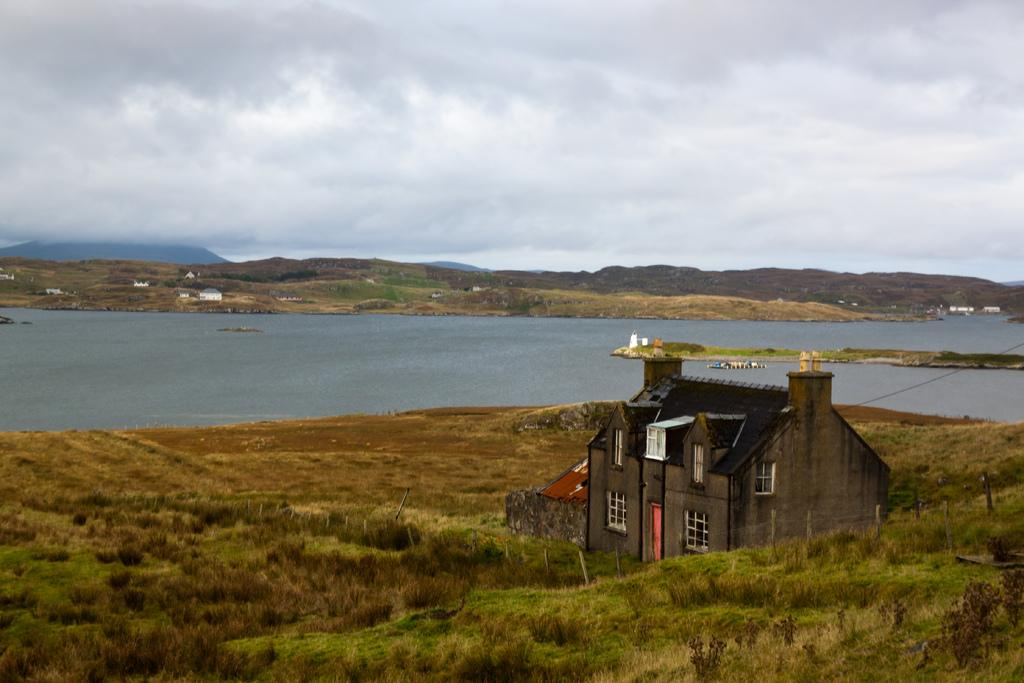What type of structure is present in the image? There is a house in the image. What type of vegetation can be seen in the image? There are plants in the image. What natural element is visible in the image? Water is visible in the image. What part of the natural environment is visible in the image? The sky is visible in the image. What type of cough medicine is visible in the image? There is no cough medicine present in the image. What type of religious symbol can be seen in the image? There is no religious symbol present in the image. What type of minister is visible in the image? There is no minister present in the image. 